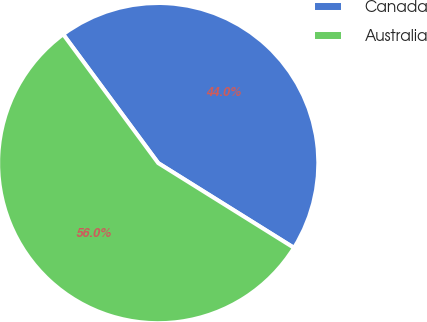<chart> <loc_0><loc_0><loc_500><loc_500><pie_chart><fcel>Canada<fcel>Australia<nl><fcel>44.0%<fcel>56.0%<nl></chart> 